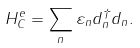<formula> <loc_0><loc_0><loc_500><loc_500>H _ { C } ^ { e } = \sum _ { n } \varepsilon _ { n } d ^ { \dag } _ { n } d _ { n } .</formula> 